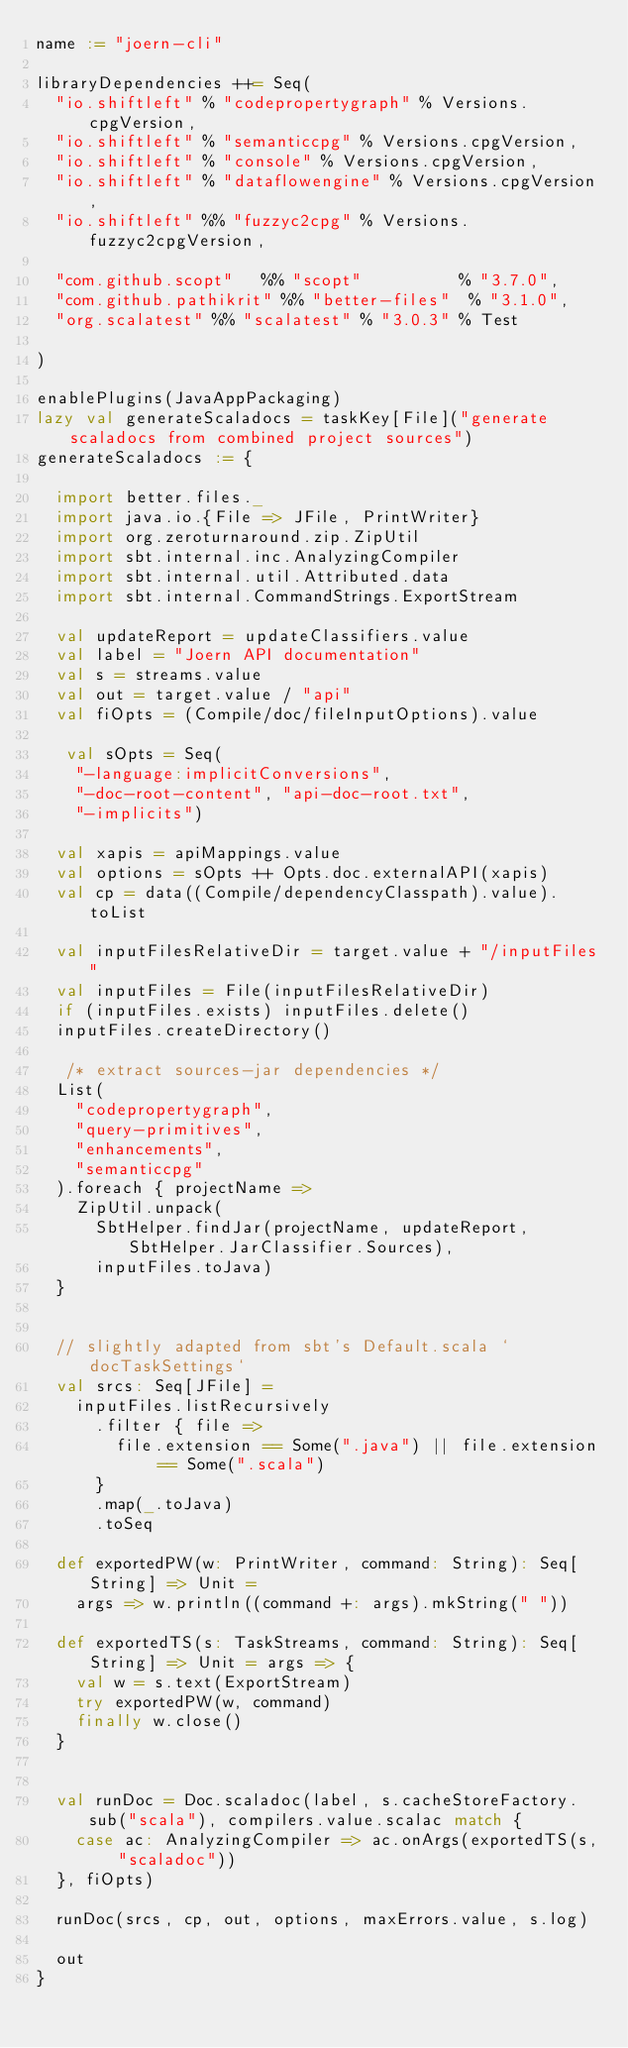<code> <loc_0><loc_0><loc_500><loc_500><_Scala_>name := "joern-cli"

libraryDependencies ++= Seq(
  "io.shiftleft" % "codepropertygraph" % Versions.cpgVersion,
  "io.shiftleft" % "semanticcpg" % Versions.cpgVersion,
  "io.shiftleft" % "console" % Versions.cpgVersion,
  "io.shiftleft" % "dataflowengine" % Versions.cpgVersion,
  "io.shiftleft" %% "fuzzyc2cpg" % Versions.fuzzyc2cpgVersion,

  "com.github.scopt"   %% "scopt"          % "3.7.0",
  "com.github.pathikrit" %% "better-files"  % "3.1.0",
  "org.scalatest" %% "scalatest" % "3.0.3" % Test

)

enablePlugins(JavaAppPackaging)
lazy val generateScaladocs = taskKey[File]("generate scaladocs from combined project sources")
generateScaladocs := {

  import better.files._
  import java.io.{File => JFile, PrintWriter}
  import org.zeroturnaround.zip.ZipUtil
  import sbt.internal.inc.AnalyzingCompiler
  import sbt.internal.util.Attributed.data
  import sbt.internal.CommandStrings.ExportStream

  val updateReport = updateClassifiers.value
  val label = "Joern API documentation"
  val s = streams.value
  val out = target.value / "api"
  val fiOpts = (Compile/doc/fileInputOptions).value

   val sOpts = Seq(
    "-language:implicitConversions",
    "-doc-root-content", "api-doc-root.txt",
    "-implicits")

  val xapis = apiMappings.value
  val options = sOpts ++ Opts.doc.externalAPI(xapis)
  val cp = data((Compile/dependencyClasspath).value).toList

  val inputFilesRelativeDir = target.value + "/inputFiles"
  val inputFiles = File(inputFilesRelativeDir)
  if (inputFiles.exists) inputFiles.delete()
  inputFiles.createDirectory()

   /* extract sources-jar dependencies */
  List(
    "codepropertygraph",
    "query-primitives",
    "enhancements",
    "semanticcpg"
  ).foreach { projectName =>
    ZipUtil.unpack(
      SbtHelper.findJar(projectName, updateReport, SbtHelper.JarClassifier.Sources),
      inputFiles.toJava)
  }


  // slightly adapted from sbt's Default.scala `docTaskSettings`
  val srcs: Seq[JFile] =
    inputFiles.listRecursively
      .filter { file =>
        file.extension == Some(".java") || file.extension == Some(".scala")
      }
      .map(_.toJava)
      .toSeq

  def exportedPW(w: PrintWriter, command: String): Seq[String] => Unit =
    args => w.println((command +: args).mkString(" "))

  def exportedTS(s: TaskStreams, command: String): Seq[String] => Unit = args => {
    val w = s.text(ExportStream)
    try exportedPW(w, command)
    finally w.close()
  }


  val runDoc = Doc.scaladoc(label, s.cacheStoreFactory.sub("scala"), compilers.value.scalac match {
    case ac: AnalyzingCompiler => ac.onArgs(exportedTS(s, "scaladoc"))
  }, fiOpts)

  runDoc(srcs, cp, out, options, maxErrors.value, s.log)

  out
}
</code> 